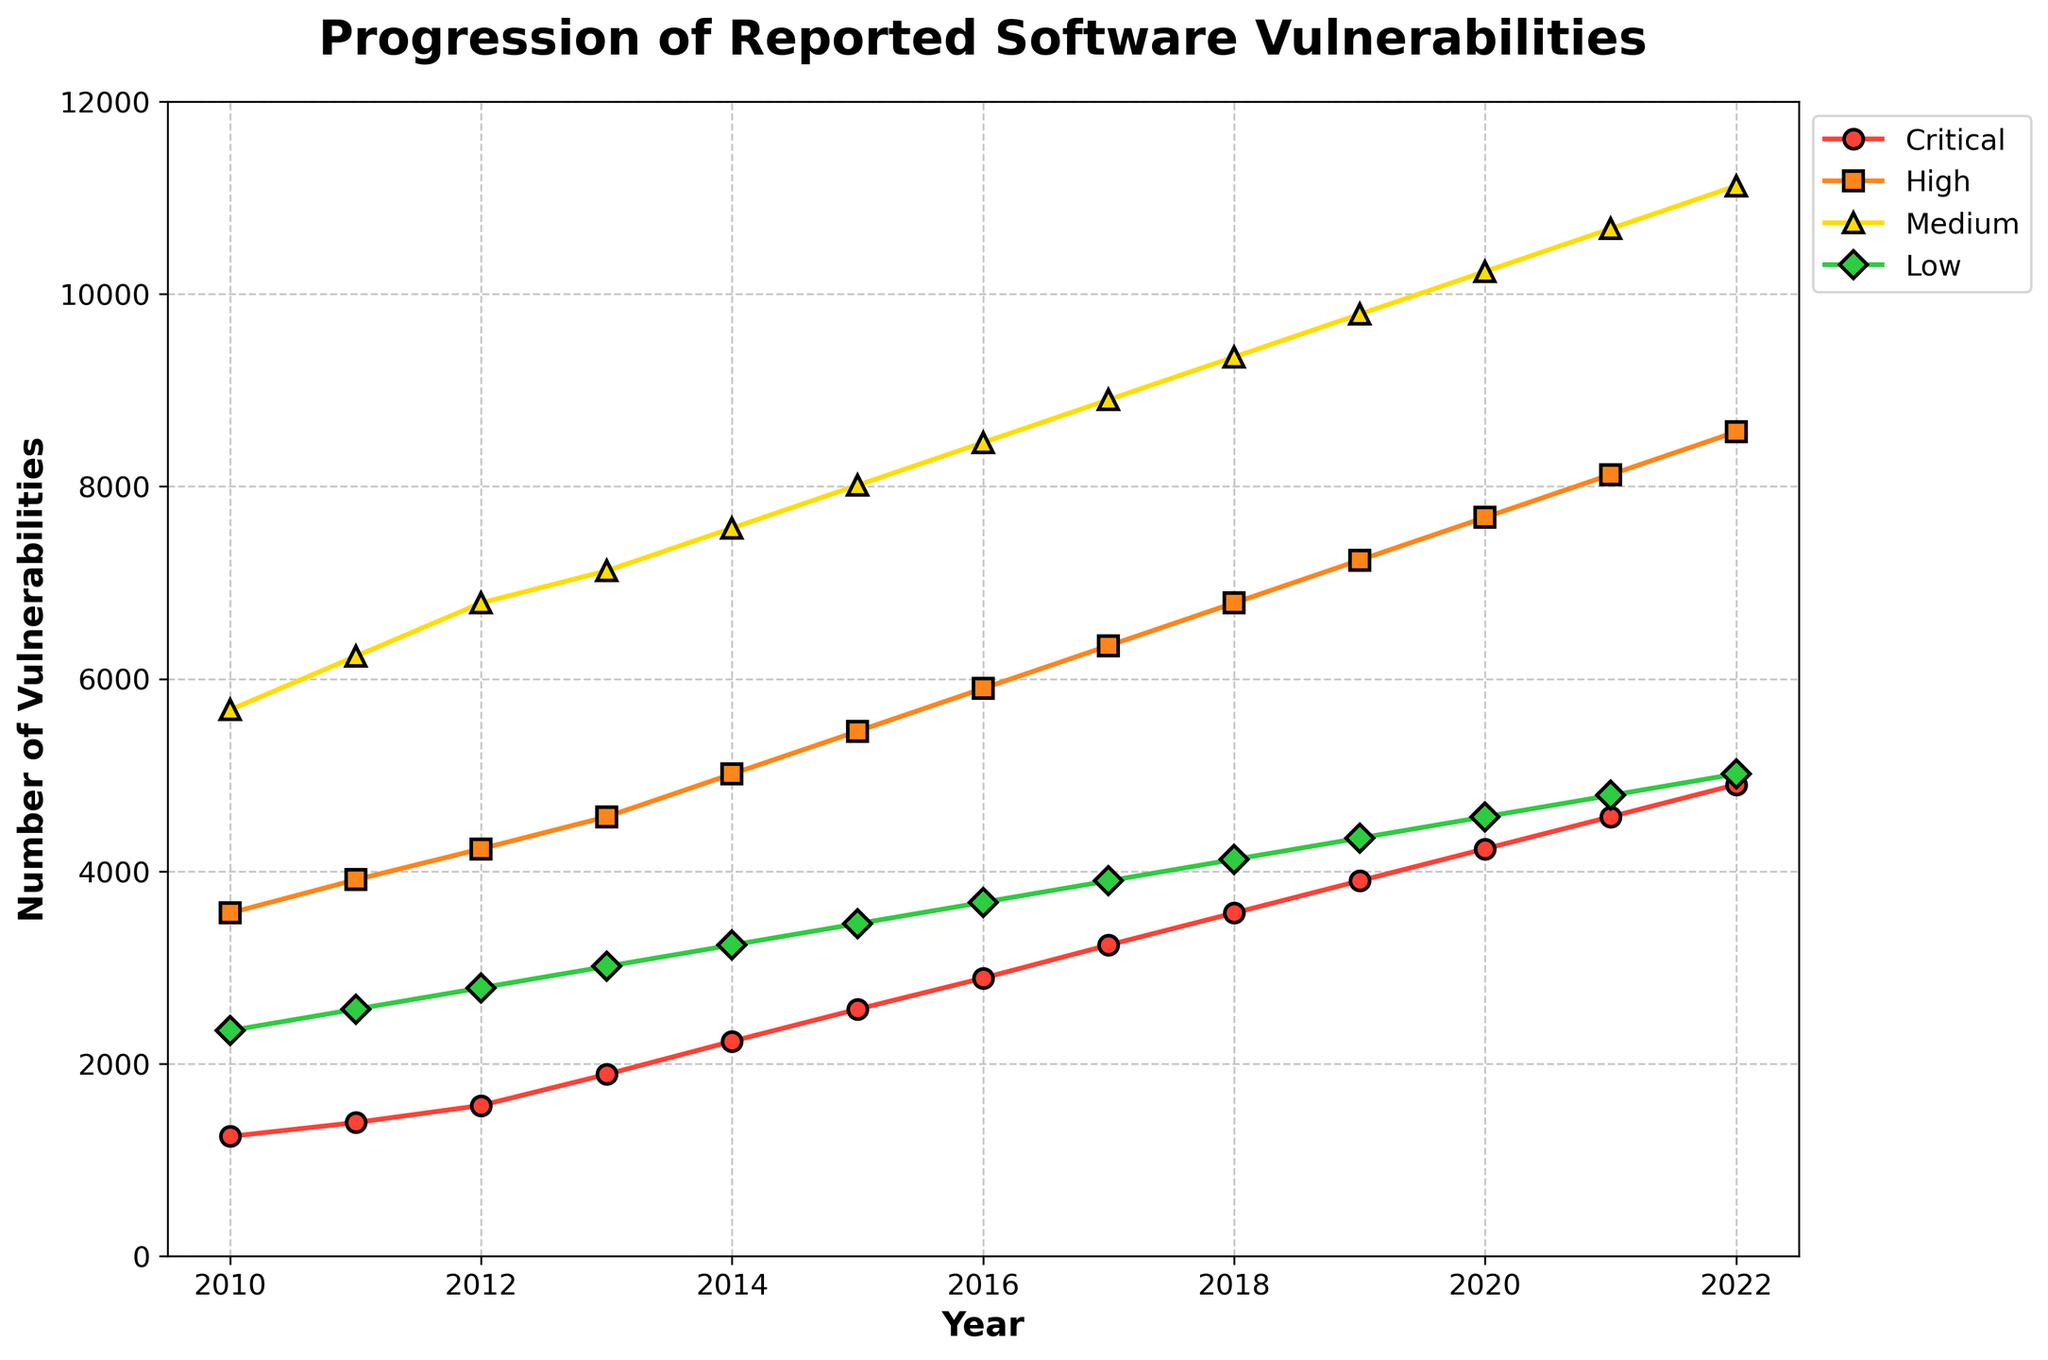What year had the highest number of reported critical vulnerabilities? Look for the peak on the line representing Critical vulnerabilities. The highest point occurs in 2022.
Answer: 2022 By how much did the number of high-severity vulnerabilities increase from 2013 to 2020? Identify the numbers for High in 2013 and 2020, which are 4567 and 7678 respectively. Subtract the 2013 value from the 2020 value: 7678 - 4567 = 3111.
Answer: 3111 Which severity level shows the most consistent upward trend from 2010 to 2022? Compare the slopes of the lines for Critical, High, Medium, and Low vulnerabilities. Each shows an increasing trend, but the line for Medium vulnerabilities has the steepest and most constant upward trend.
Answer: Medium In which year did Medium-severity vulnerabilities surpass 10,000 for the first time? Look at the line representing Medium vulnerabilities and find where it first exceeds 10,000. This occurs in 2020.
Answer: 2020 By what percentage did the number of low-severity vulnerabilities increase from 2010 to 2022? Identify the values for Low vulnerabilities in 2010 (2345) and 2022 (5012). Calculate the percentage increase: [(5012 - 2345) / 2345] * 100 ≈ 113.86%.
Answer: 113.86% Which year saw the smallest gap between high and critical severity vulnerabilities? Calculate the differences for each year. In 2010, the gap is 3567 - 1245 = 2322. Comparing all years, 2022 has the smallest gap with a difference of 8567 - 4901 = 3666.
Answer: 2010 What is the total number of vulnerabilities reported in 2019 across all severity levels? Sum the values for all severity levels in 2019: 3901 (Critical) + 7234 (High) + 9789 (Medium) + 4345 (Low) = 25269.
Answer: 25269 How did the number of low-severity vulnerabilities change between 2011 and 2018, and what's the average annual increase? The number of Low vulnerabilities in 2011 is 2567, and in 2018 it's 4123. The increase is 4123 - 2567 = 1556. The number of years between 2011 and 2018 is 7. So, the average annual increase is 1556 / 7 ≈ 222.29.
Answer: ≈ 222.29 In which year did the difference between Medium and Low vulnerabilities exceed 5000 for the first time? Calculate the differences for each year. In 2012, the difference is 6789 - 2789 = 4000 and not exceeded 5000. In 2013, it is 7123 - 3012 = 4111, also less. In 2014, the difference is 7567 - 3234 = 4333. Continuing this way, we find in 2015 the difference is 8012 - 3456 = 4556 and not yet 5000. Finally, 2016 shows 8456 - 3678 = 4778. Then, in 2017: 8901 - 3901 = 5000 exactly. So, the difference of more than 5000 appears in 2018: 9345 - 4123 = 5222.
Answer: 2018 